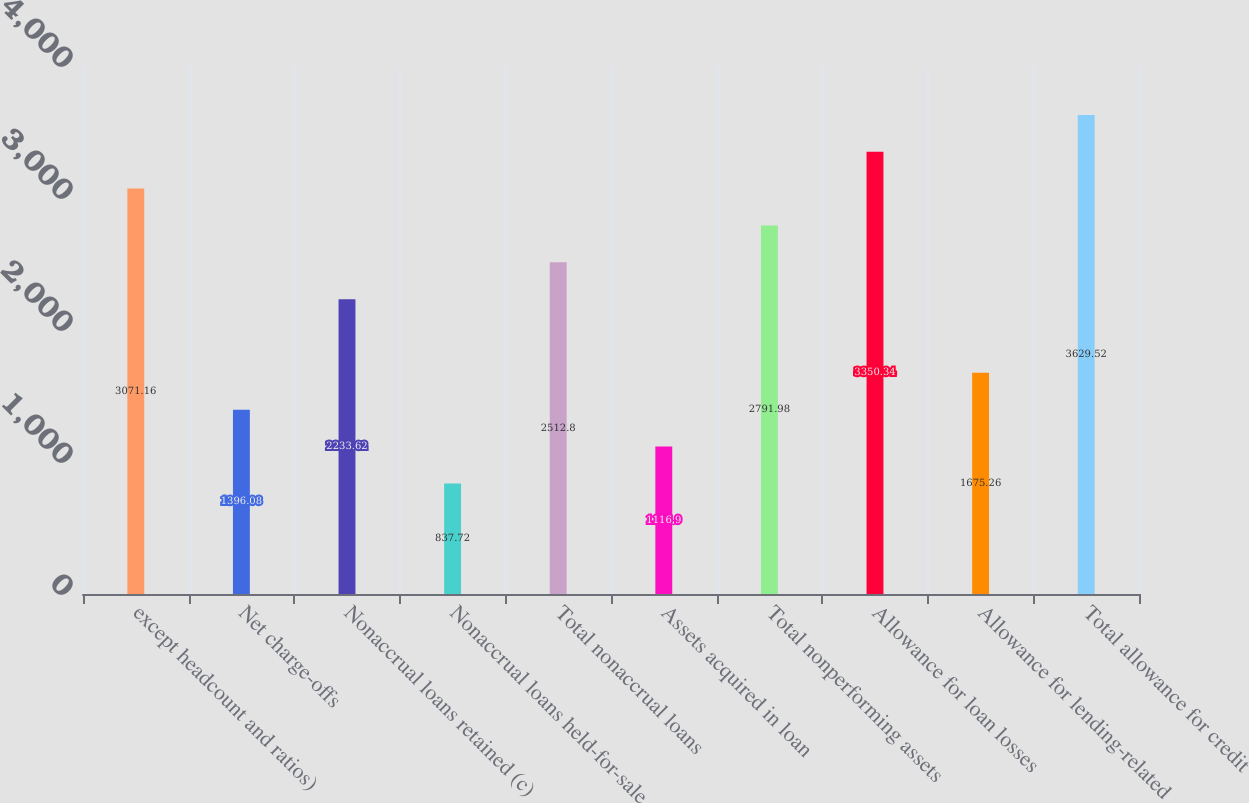Convert chart. <chart><loc_0><loc_0><loc_500><loc_500><bar_chart><fcel>except headcount and ratios)<fcel>Net charge-offs<fcel>Nonaccrual loans retained (c)<fcel>Nonaccrual loans held-for-sale<fcel>Total nonaccrual loans<fcel>Assets acquired in loan<fcel>Total nonperforming assets<fcel>Allowance for loan losses<fcel>Allowance for lending-related<fcel>Total allowance for credit<nl><fcel>3071.16<fcel>1396.08<fcel>2233.62<fcel>837.72<fcel>2512.8<fcel>1116.9<fcel>2791.98<fcel>3350.34<fcel>1675.26<fcel>3629.52<nl></chart> 